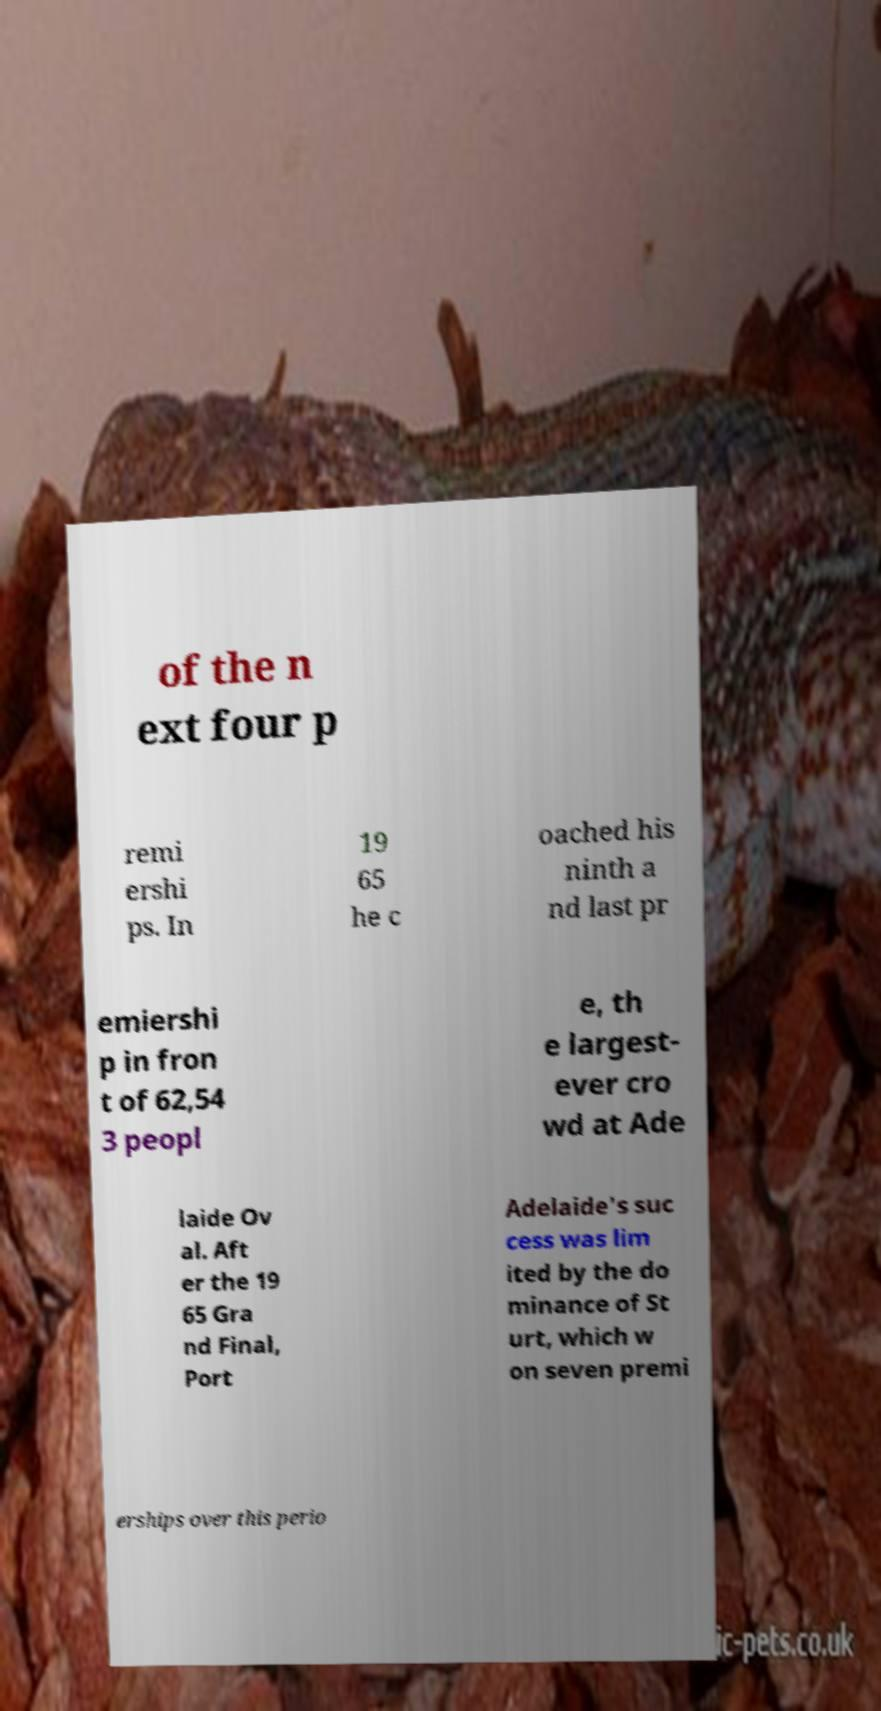What messages or text are displayed in this image? I need them in a readable, typed format. of the n ext four p remi ershi ps. In 19 65 he c oached his ninth a nd last pr emiershi p in fron t of 62,54 3 peopl e, th e largest- ever cro wd at Ade laide Ov al. Aft er the 19 65 Gra nd Final, Port Adelaide's suc cess was lim ited by the do minance of St urt, which w on seven premi erships over this perio 